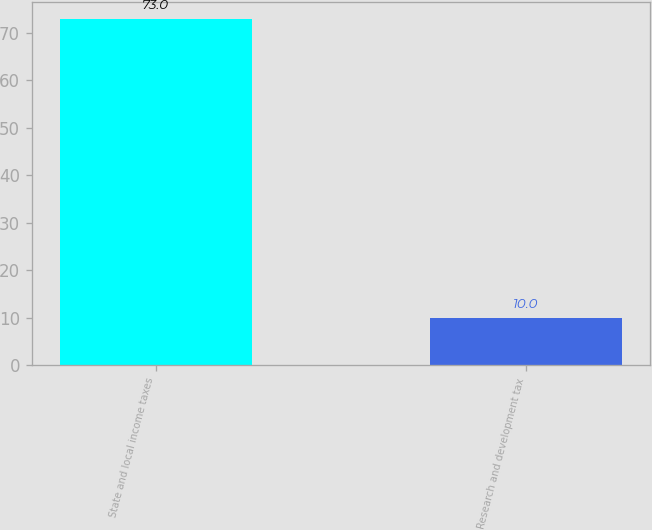<chart> <loc_0><loc_0><loc_500><loc_500><bar_chart><fcel>State and local income taxes<fcel>Research and development tax<nl><fcel>73<fcel>10<nl></chart> 